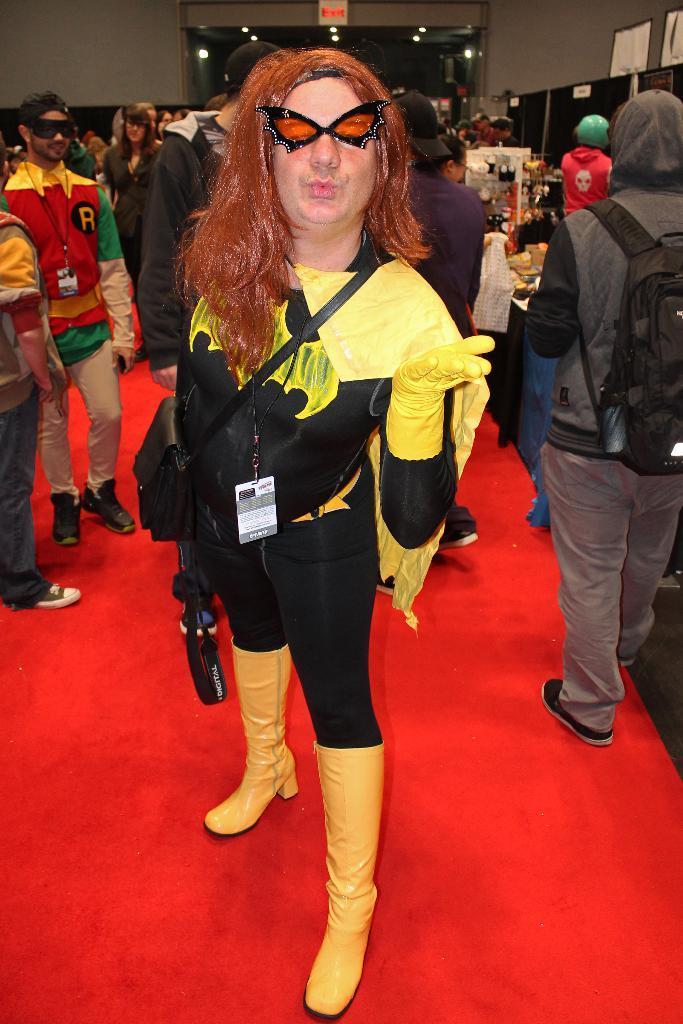In one or two sentences, can you explain what this image depicts? There is a person in a black and yellow costume is wearing gloves, boots, bag, tag and a butterfly shaped eye mask. In the back there are many people. There is a red carpet. Also in the background there is an exit board and a wall. 